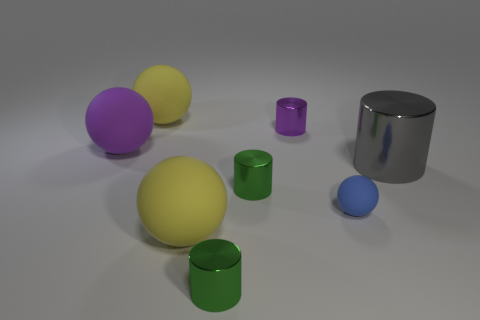Subtract all tiny purple cylinders. How many cylinders are left? 3 Add 2 gray shiny cylinders. How many objects exist? 10 Subtract 0 cyan spheres. How many objects are left? 8 Subtract 1 cylinders. How many cylinders are left? 3 Subtract all blue cylinders. Subtract all brown spheres. How many cylinders are left? 4 Subtract all red spheres. How many green cylinders are left? 2 Subtract all metal objects. Subtract all big purple spheres. How many objects are left? 3 Add 4 rubber spheres. How many rubber spheres are left? 8 Add 5 gray things. How many gray things exist? 6 Subtract all purple spheres. How many spheres are left? 3 